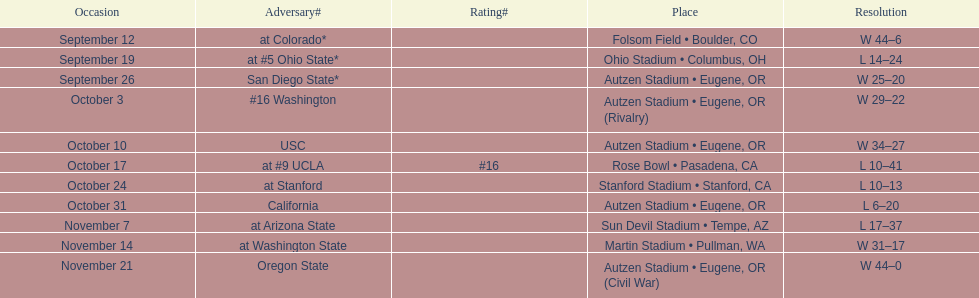Who was their last opponent of the season? Oregon State. 